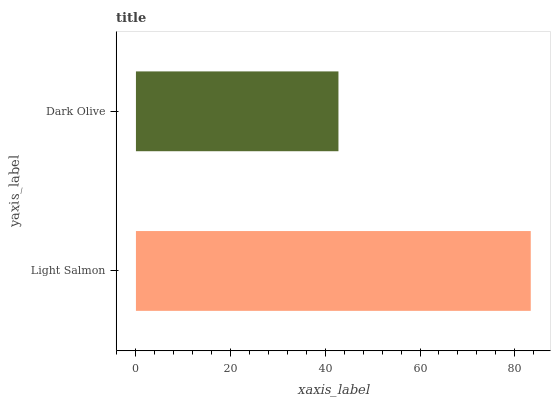Is Dark Olive the minimum?
Answer yes or no. Yes. Is Light Salmon the maximum?
Answer yes or no. Yes. Is Dark Olive the maximum?
Answer yes or no. No. Is Light Salmon greater than Dark Olive?
Answer yes or no. Yes. Is Dark Olive less than Light Salmon?
Answer yes or no. Yes. Is Dark Olive greater than Light Salmon?
Answer yes or no. No. Is Light Salmon less than Dark Olive?
Answer yes or no. No. Is Light Salmon the high median?
Answer yes or no. Yes. Is Dark Olive the low median?
Answer yes or no. Yes. Is Dark Olive the high median?
Answer yes or no. No. Is Light Salmon the low median?
Answer yes or no. No. 